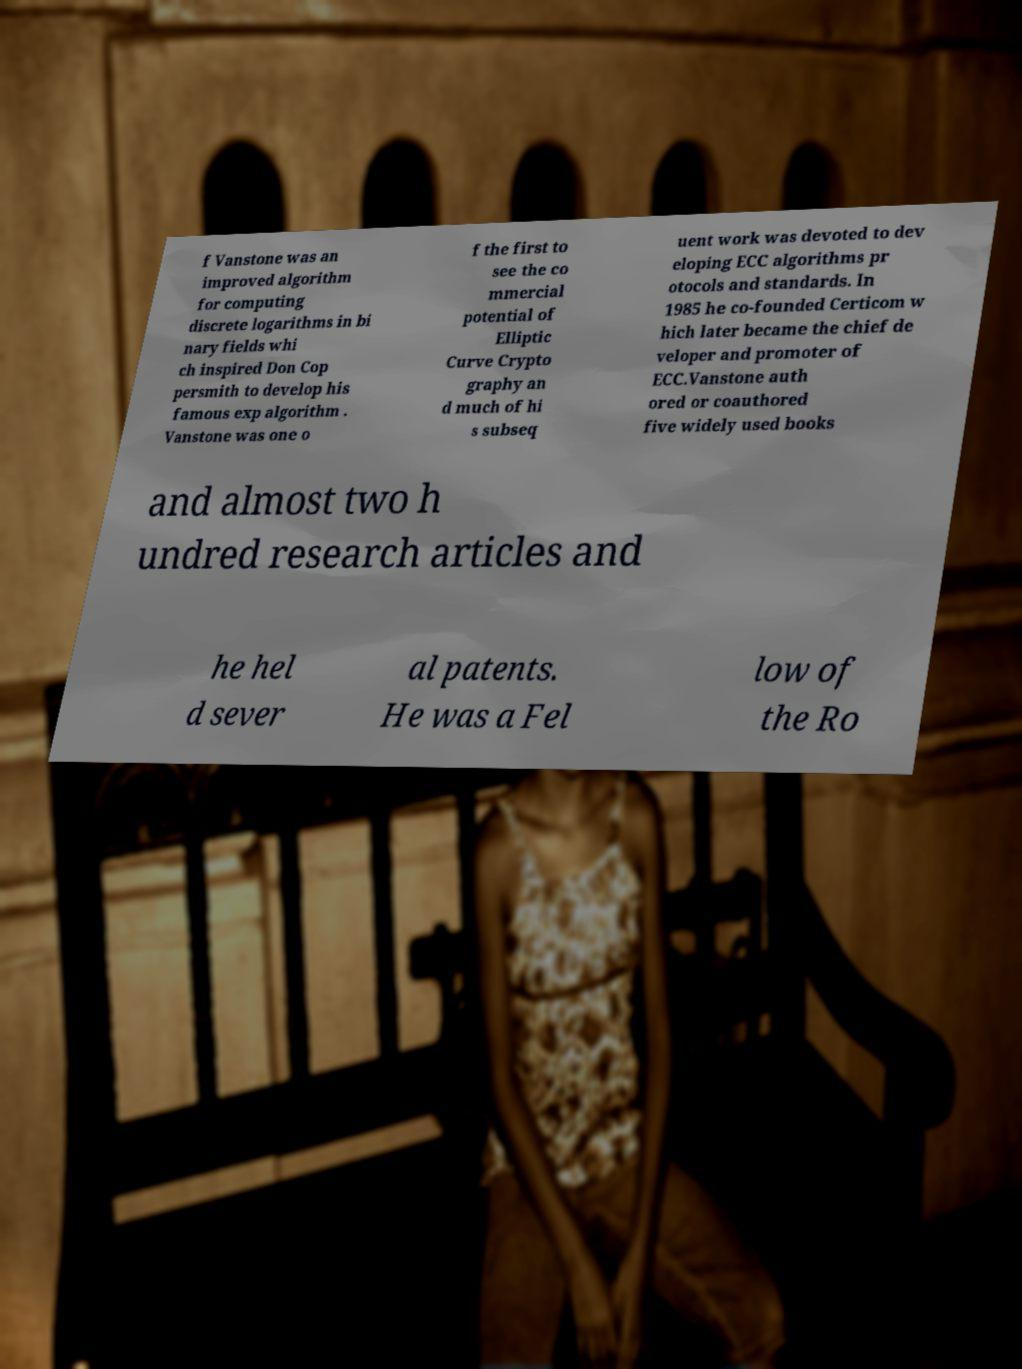Can you accurately transcribe the text from the provided image for me? f Vanstone was an improved algorithm for computing discrete logarithms in bi nary fields whi ch inspired Don Cop persmith to develop his famous exp algorithm . Vanstone was one o f the first to see the co mmercial potential of Elliptic Curve Crypto graphy an d much of hi s subseq uent work was devoted to dev eloping ECC algorithms pr otocols and standards. In 1985 he co-founded Certicom w hich later became the chief de veloper and promoter of ECC.Vanstone auth ored or coauthored five widely used books and almost two h undred research articles and he hel d sever al patents. He was a Fel low of the Ro 